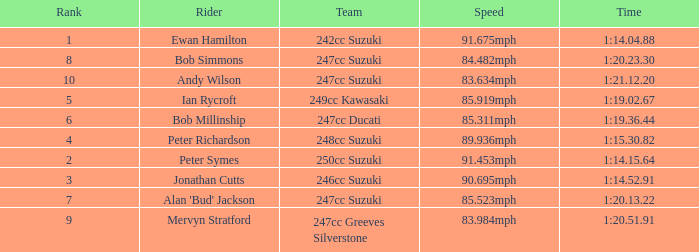Help me parse the entirety of this table. {'header': ['Rank', 'Rider', 'Team', 'Speed', 'Time'], 'rows': [['1', 'Ewan Hamilton', '242cc Suzuki', '91.675mph', '1:14.04.88'], ['8', 'Bob Simmons', '247cc Suzuki', '84.482mph', '1:20.23.30'], ['10', 'Andy Wilson', '247cc Suzuki', '83.634mph', '1:21.12.20'], ['5', 'Ian Rycroft', '249cc Kawasaki', '85.919mph', '1:19.02.67'], ['6', 'Bob Millinship', '247cc Ducati', '85.311mph', '1:19.36.44'], ['4', 'Peter Richardson', '248cc Suzuki', '89.936mph', '1:15.30.82'], ['2', 'Peter Symes', '250cc Suzuki', '91.453mph', '1:14.15.64'], ['3', 'Jonathan Cutts', '246cc Suzuki', '90.695mph', '1:14.52.91'], ['7', "Alan 'Bud' Jackson", '247cc Suzuki', '85.523mph', '1:20.13.22'], ['9', 'Mervyn Stratford', '247cc Greeves Silverstone', '83.984mph', '1:20.51.91']]} Which team had a rank under 4 with a time of 1:14.04.88? 242cc Suzuki. 